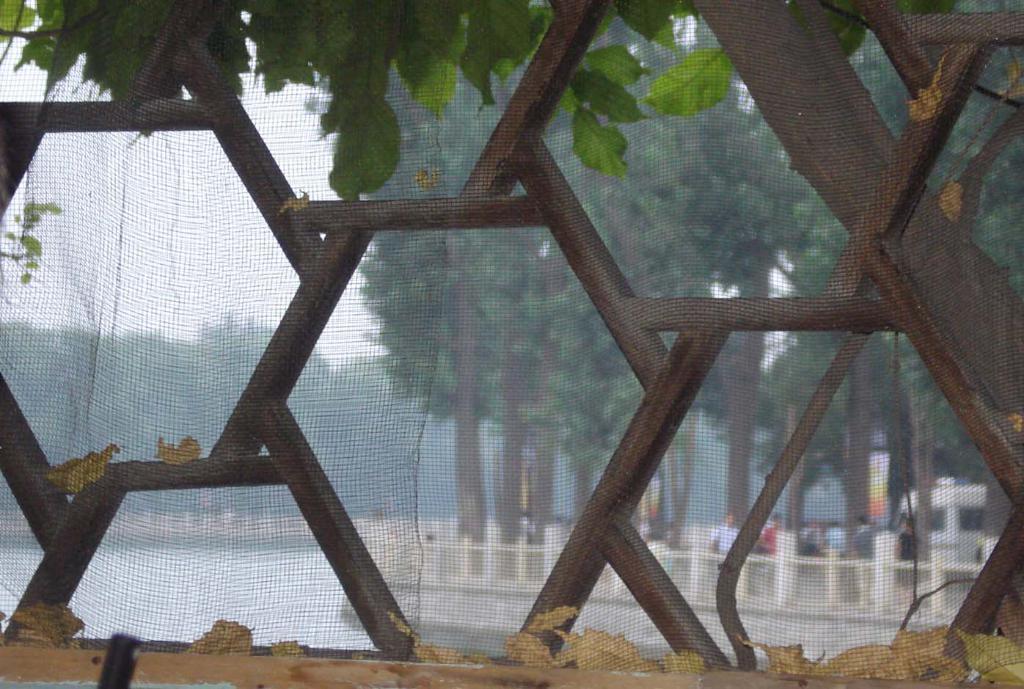Could you give a brief overview of what you see in this image? In this image, we can see some net with grill. Through the net, we can see the other side view. There are so many trees, water, rod fencing, few people and sky we can see. 